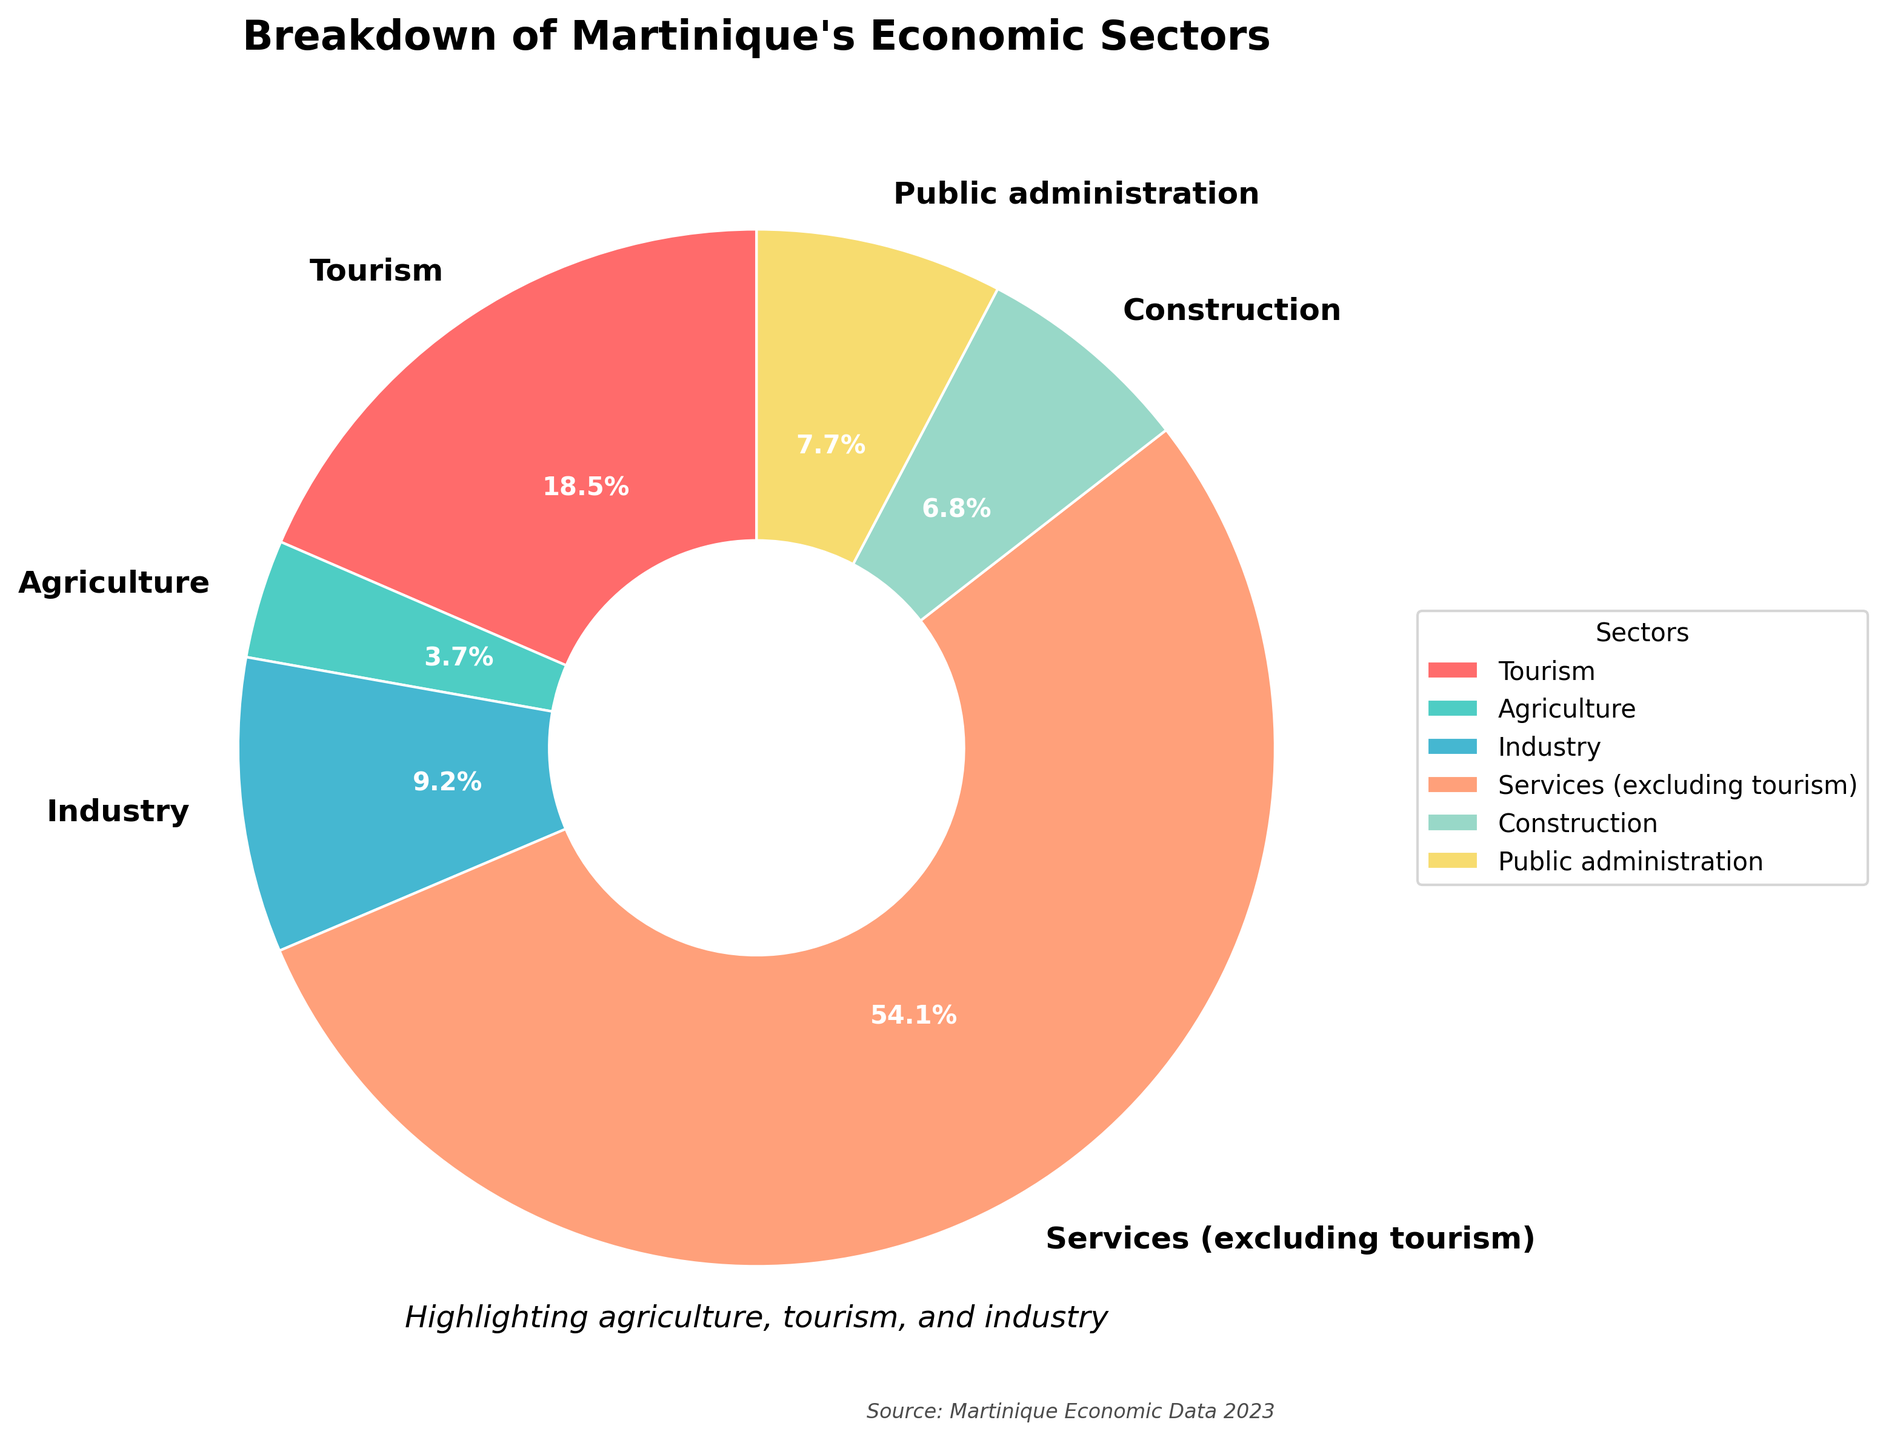What percentage of Martinique's economy is attributed to the Industry sector? Look for the sector labeled 'Industry' and refer to its corresponding percentage in the pie chart
Answer: 9.2% What is the combined percentage of the Agriculture and Tourism sectors? Identify the percentages for the Agriculture (3.7%) and Tourism (18.5%) sectors from the pie chart, then add these percentages: 3.7 + 18.5 = 22.2%
Answer: 22.2% Which sector, Agriculture or Public Administration, has a higher percentage? Compare the slices labeled 'Agriculture' and 'Public Administration' from the pie chart. Agriculture is 3.7%, and Public Administration is 7.7%, so Public Administration is higher
Answer: Public Administration How much larger is the percentage of the Services (excluding tourism) sector compared to the Construction sector? Identify the percentages for Services (excluding tourism) (54.1%) and Construction (6.8%) from the pie chart, then subtract the smaller from the larger: 54.1 - 6.8 = 47.3%
Answer: 47.3% Which sector has the smallest percentage, and what is it? Refer to the pie chart and identify the sector with the smallest slice, which is 'Agriculture' with 3.7%
Answer: Agriculture, 3.7% Is the percentage of the Tourism sector more than double the percentage of the Industry sector? Check the pie chart for the percentages of Tourism (18.5%) and Industry (9.2%), then determine if 18.5% is more than twice 9.2%. 9.2% × 2 = 18.4%, and since 18.5% is slightly more than 18.4%, the answer is yes
Answer: Yes What is the difference in percentage between the construction sector and agriculture sector? Look at the percentages for Construction (6.8%) and Agriculture (3.7%) in the pie chart. Subtract the smaller from the larger: 6.8 - 3.7 = 3.1%
Answer: 3.1% If you combined Industry and Public Administration, would their total percentage be greater than that of Services (excluding tourism)? Identify the percentages for Industry (9.2%) and Public Administration (7.7%) from the pie chart and sum them: 9.2 + 7.7 = 16.9%. Compare this with Services (excluding tourism) at 54.1%; 16.9% is less than 54.1%
Answer: No What is the visual cue used to distinguish the different sectors in the pie chart? Observe the pie chart to identify what distinguishes each sector visually. Colors are used to differentiate between sectors
Answer: Colors How many sectors have a percentage that is below 10%? From the pie chart, identify the sectors with a percentage less than 10%: Agriculture (3.7%), Industry (9.2%), and Construction (6.8%). There are 3 such sectors
Answer: 3 